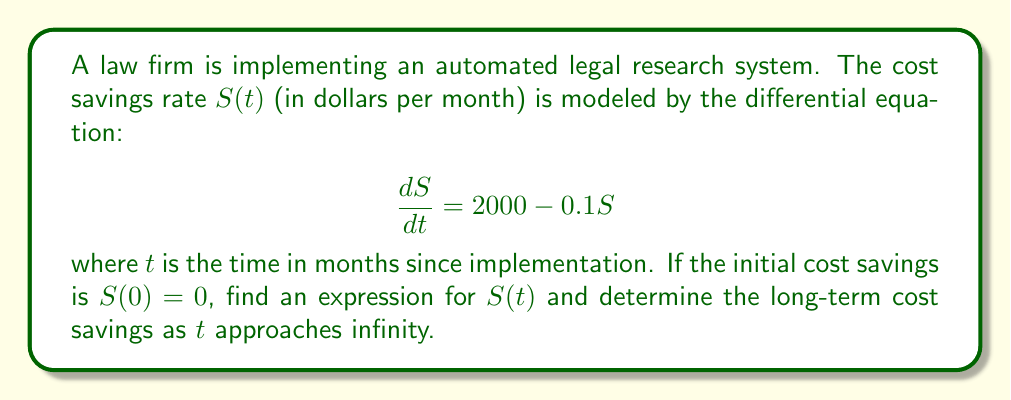What is the answer to this math problem? To solve this first-order linear differential equation, we follow these steps:

1) The differential equation is in the form:
   $$\frac{dS}{dt} + 0.1S = 2000$$

2) This is a first-order linear differential equation of the form:
   $$\frac{dy}{dx} + P(x)y = Q(x)$$
   where $P(x) = 0.1$ and $Q(x) = 2000$

3) The integrating factor is:
   $$\mu(t) = e^{\int P(t) dt} = e^{\int 0.1 dt} = e^{0.1t}$$

4) Multiply both sides of the equation by the integrating factor:
   $$e^{0.1t}\frac{dS}{dt} + 0.1e^{0.1t}S = 2000e^{0.1t}$$

5) The left side is now the derivative of $e^{0.1t}S$:
   $$\frac{d}{dt}(e^{0.1t}S) = 2000e^{0.1t}$$

6) Integrate both sides:
   $$e^{0.1t}S = 20000e^{0.1t} + C$$

7) Solve for $S$:
   $$S(t) = 20000 + Ce^{-0.1t}$$

8) Use the initial condition $S(0) = 0$ to find $C$:
   $$0 = 20000 + C$$
   $$C = -20000$$

9) The final solution is:
   $$S(t) = 20000(1 - e^{-0.1t})$$

10) To find the long-term cost savings, take the limit as $t$ approaches infinity:
    $$\lim_{t \to \infty} S(t) = \lim_{t \to \infty} 20000(1 - e^{-0.1t}) = 20000$$

Thus, the long-term monthly cost savings approaches $20,000.
Answer: $S(t) = 20000(1 - e^{-0.1t})$, with long-term monthly cost savings of $20,000. 